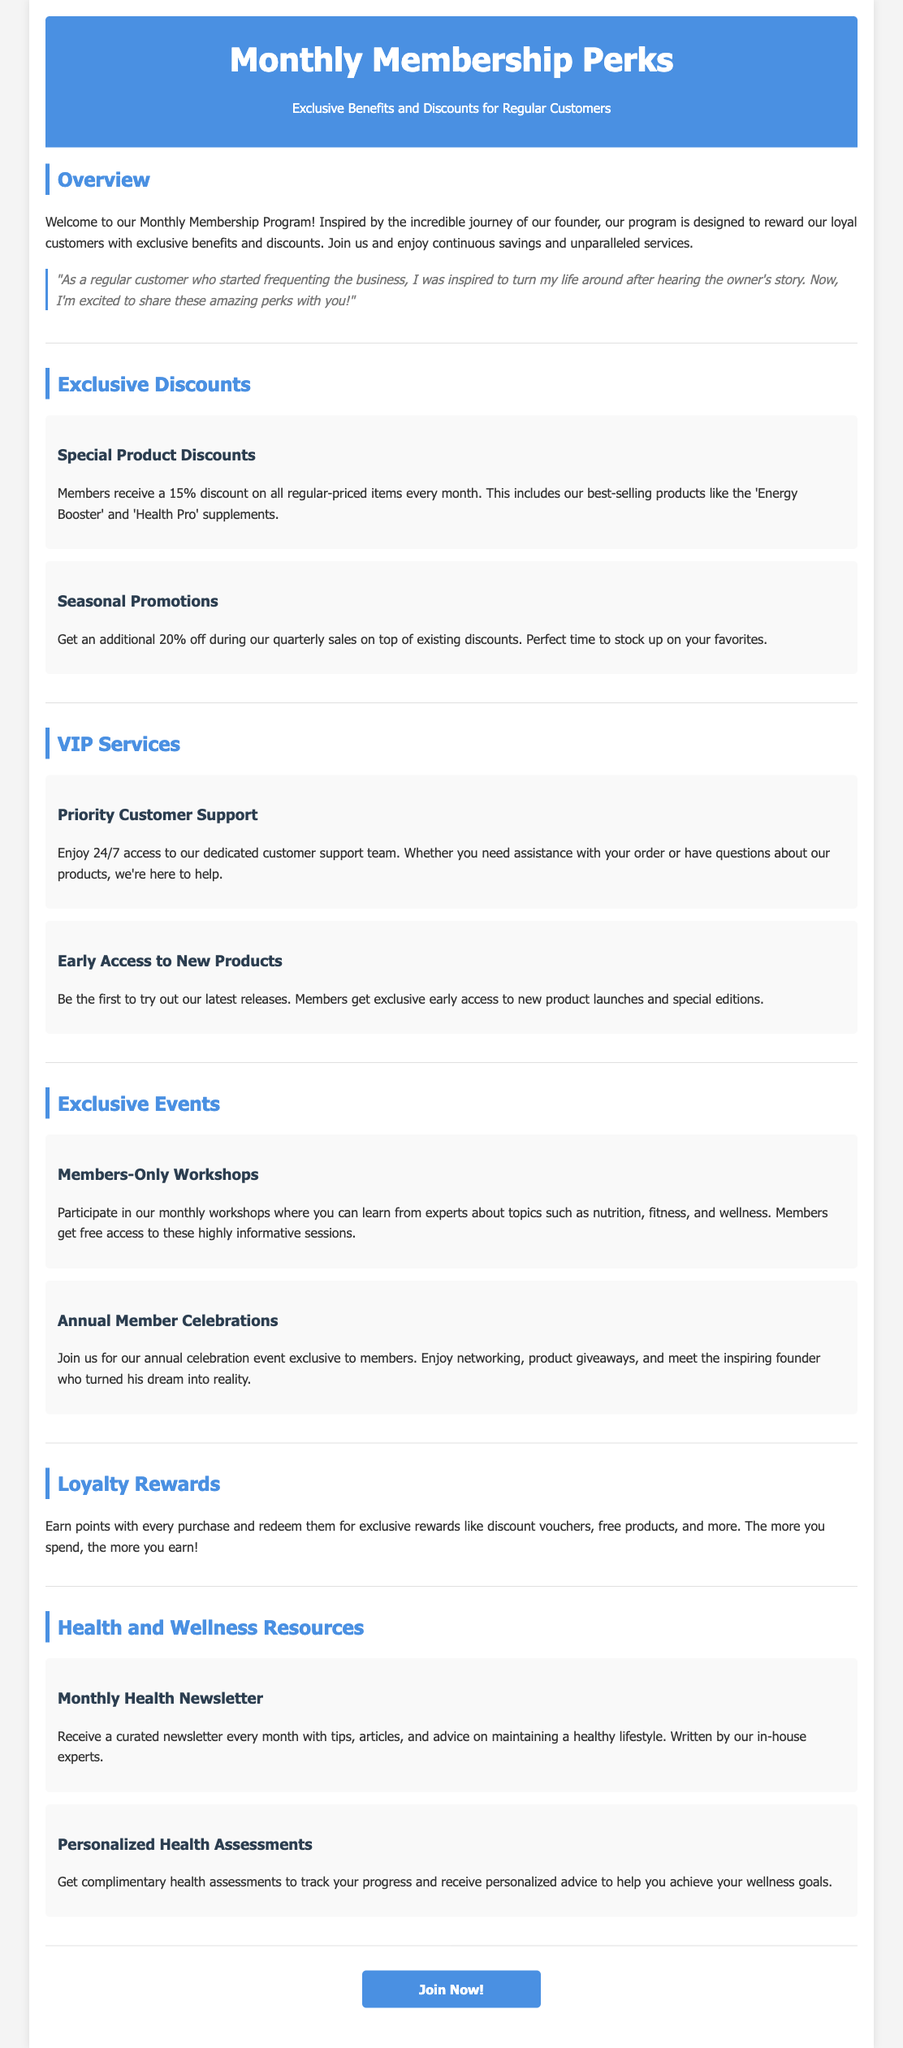What is the percentage discount members receive on regular-priced items? Members receive a 15% discount on all regular-priced items every month.
Answer: 15% What kind of support can members access? Members enjoy 24/7 access to a dedicated customer support team.
Answer: 24/7 support How often do members receive the health newsletter? Members receive a curated newsletter every month with tips, articles, and advice.
Answer: Monthly What additional discount do members receive during quarterly sales? Members get an additional 20% off during quarterly sales on top of existing discounts.
Answer: 20% What is one of the benefits of being a member regarding new products? Members get exclusive early access to new product launches and special editions.
Answer: Early access What do members earn with every purchase? Members earn points with every purchase redeemable for rewards.
Answer: Points What type of workshops do members participate in? Members participate in monthly workshops covering nutrition, fitness, and wellness.
Answer: Monthly workshops How often is the annual member celebration held? The annual member celebration event is exclusive to members.
Answer: Annual 